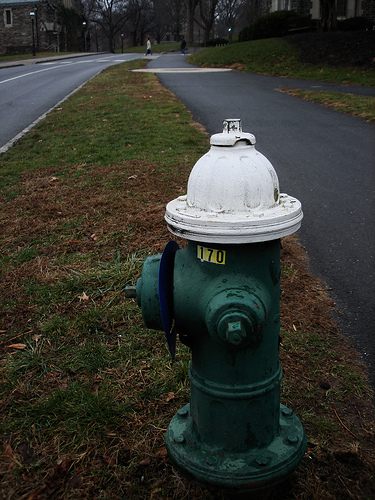Please provide a short description for this region: [0.12, 0.1, 0.38, 0.24]. This region, with coordinates [0.12, 0.1, 0.38, 0.24], clearly includes a white traffic line on the road, integral to guiding traffic and maintaining road safety. 